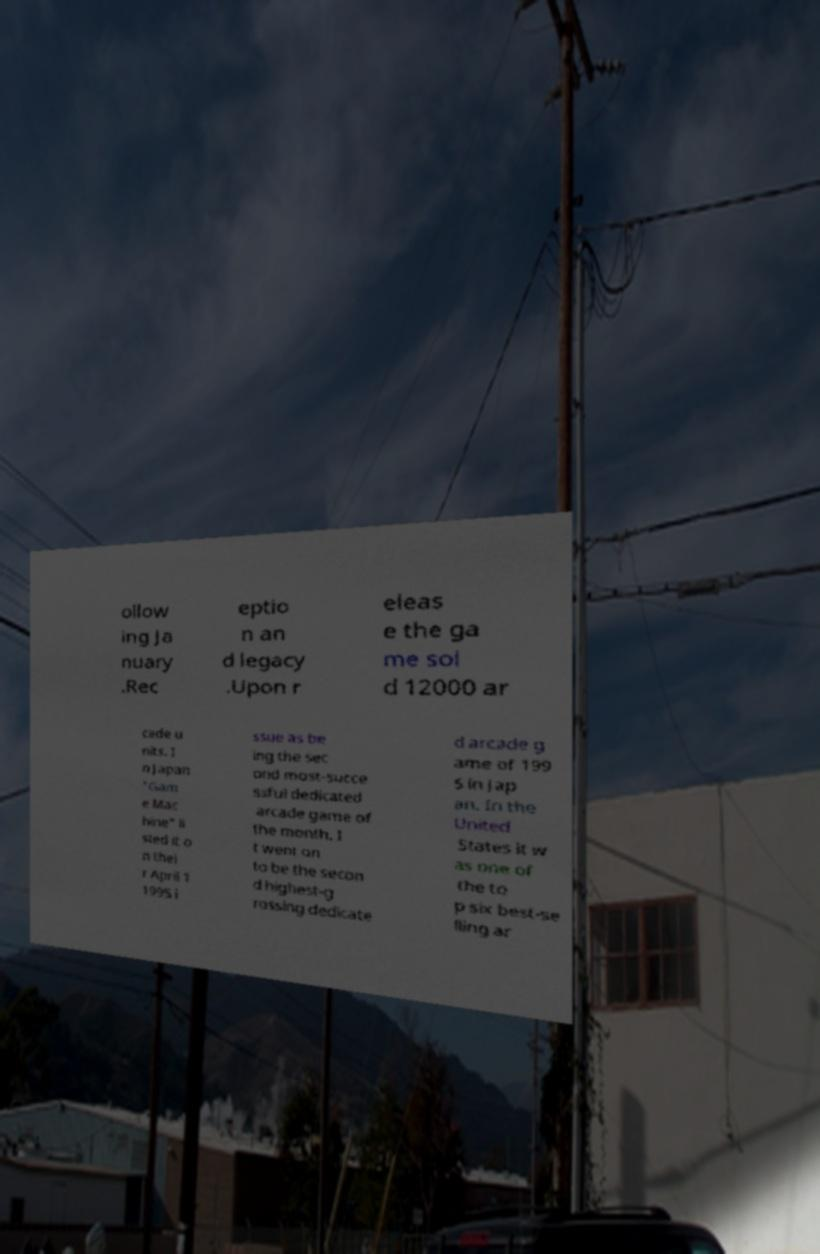There's text embedded in this image that I need extracted. Can you transcribe it verbatim? ollow ing Ja nuary .Rec eptio n an d legacy .Upon r eleas e the ga me sol d 12000 ar cade u nits. I n Japan "Gam e Mac hine" li sted it o n thei r April 1 1995 i ssue as be ing the sec ond most-succe ssful dedicated arcade game of the month. I t went on to be the secon d highest-g rossing dedicate d arcade g ame of 199 5 in Jap an. In the United States it w as one of the to p six best-se lling ar 